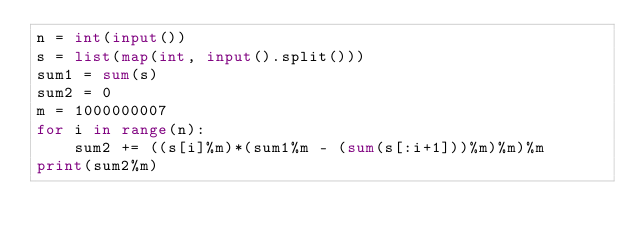<code> <loc_0><loc_0><loc_500><loc_500><_Python_>n = int(input())
s = list(map(int, input().split()))
sum1 = sum(s)
sum2 = 0
m = 1000000007
for i in range(n):
    sum2 += ((s[i]%m)*(sum1%m - (sum(s[:i+1]))%m)%m)%m
print(sum2%m)
</code> 